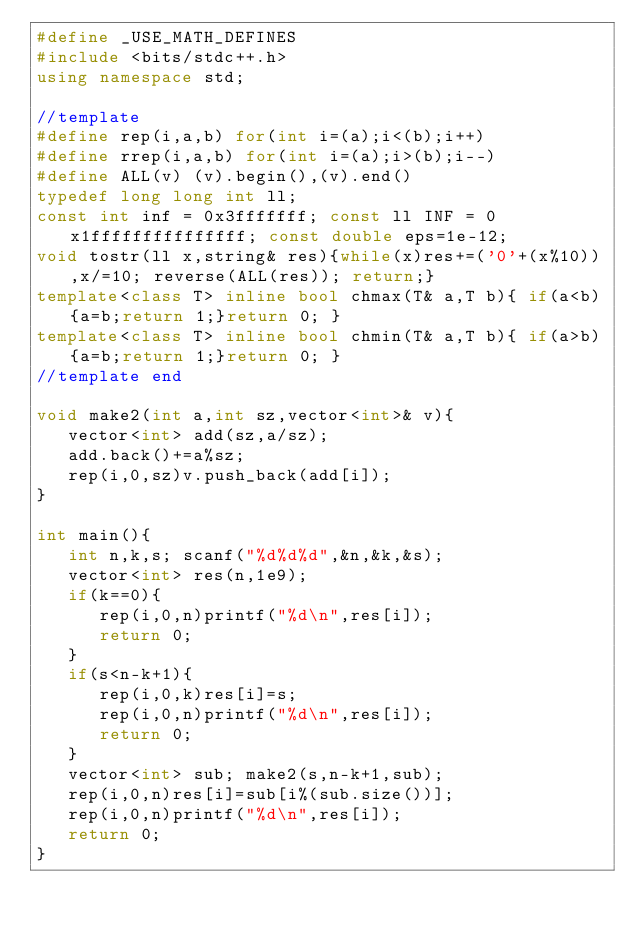Convert code to text. <code><loc_0><loc_0><loc_500><loc_500><_C++_>#define _USE_MATH_DEFINES
#include <bits/stdc++.h>
using namespace std;

//template
#define rep(i,a,b) for(int i=(a);i<(b);i++)
#define rrep(i,a,b) for(int i=(a);i>(b);i--)
#define ALL(v) (v).begin(),(v).end()
typedef long long int ll;
const int inf = 0x3fffffff; const ll INF = 0x1fffffffffffffff; const double eps=1e-12;
void tostr(ll x,string& res){while(x)res+=('0'+(x%10)),x/=10; reverse(ALL(res)); return;}
template<class T> inline bool chmax(T& a,T b){ if(a<b){a=b;return 1;}return 0; }
template<class T> inline bool chmin(T& a,T b){ if(a>b){a=b;return 1;}return 0; }
//template end

void make2(int a,int sz,vector<int>& v){
   vector<int> add(sz,a/sz);
   add.back()+=a%sz;
   rep(i,0,sz)v.push_back(add[i]);
}

int main(){
   int n,k,s; scanf("%d%d%d",&n,&k,&s);
   vector<int> res(n,1e9);
   if(k==0){
      rep(i,0,n)printf("%d\n",res[i]);
      return 0;
   }
   if(s<n-k+1){
      rep(i,0,k)res[i]=s;
      rep(i,0,n)printf("%d\n",res[i]);
      return 0;
   }
   vector<int> sub; make2(s,n-k+1,sub);
   rep(i,0,n)res[i]=sub[i%(sub.size())];
   rep(i,0,n)printf("%d\n",res[i]);
   return 0;
}
</code> 